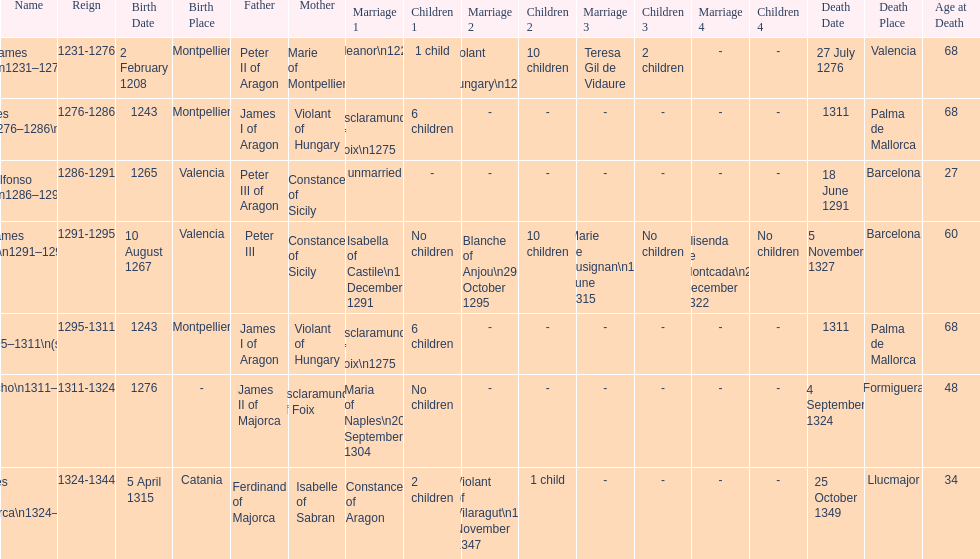Who came to power after the rule of james iii? James II. 